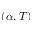Convert formula to latex. <formula><loc_0><loc_0><loc_500><loc_500>( \alpha , T )</formula> 